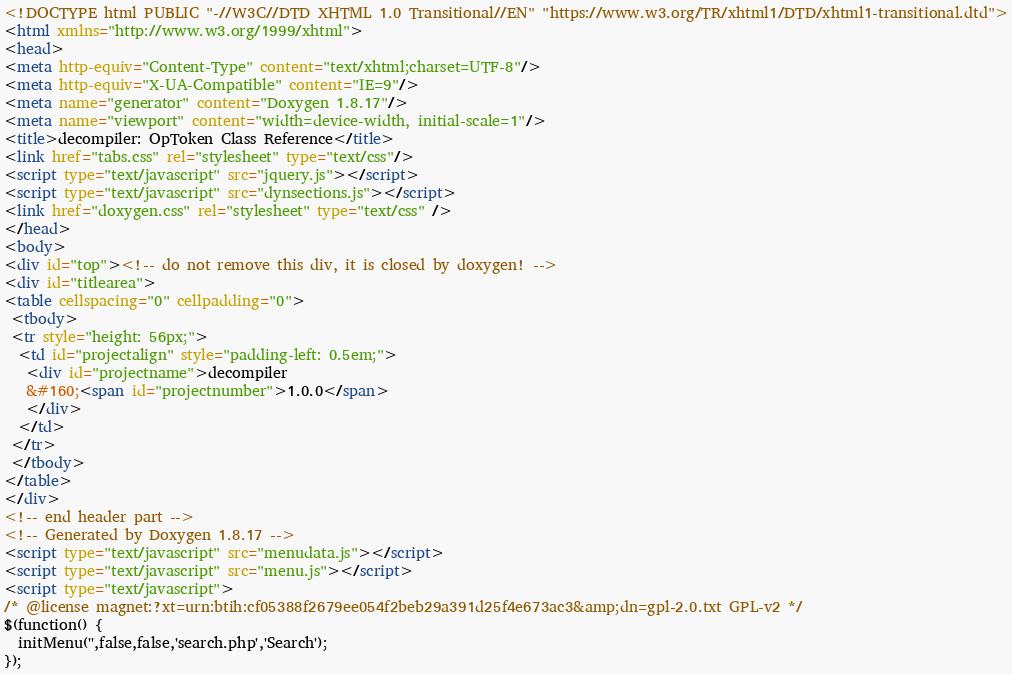Convert code to text. <code><loc_0><loc_0><loc_500><loc_500><_HTML_><!DOCTYPE html PUBLIC "-//W3C//DTD XHTML 1.0 Transitional//EN" "https://www.w3.org/TR/xhtml1/DTD/xhtml1-transitional.dtd">
<html xmlns="http://www.w3.org/1999/xhtml">
<head>
<meta http-equiv="Content-Type" content="text/xhtml;charset=UTF-8"/>
<meta http-equiv="X-UA-Compatible" content="IE=9"/>
<meta name="generator" content="Doxygen 1.8.17"/>
<meta name="viewport" content="width=device-width, initial-scale=1"/>
<title>decompiler: OpToken Class Reference</title>
<link href="tabs.css" rel="stylesheet" type="text/css"/>
<script type="text/javascript" src="jquery.js"></script>
<script type="text/javascript" src="dynsections.js"></script>
<link href="doxygen.css" rel="stylesheet" type="text/css" />
</head>
<body>
<div id="top"><!-- do not remove this div, it is closed by doxygen! -->
<div id="titlearea">
<table cellspacing="0" cellpadding="0">
 <tbody>
 <tr style="height: 56px;">
  <td id="projectalign" style="padding-left: 0.5em;">
   <div id="projectname">decompiler
   &#160;<span id="projectnumber">1.0.0</span>
   </div>
  </td>
 </tr>
 </tbody>
</table>
</div>
<!-- end header part -->
<!-- Generated by Doxygen 1.8.17 -->
<script type="text/javascript" src="menudata.js"></script>
<script type="text/javascript" src="menu.js"></script>
<script type="text/javascript">
/* @license magnet:?xt=urn:btih:cf05388f2679ee054f2beb29a391d25f4e673ac3&amp;dn=gpl-2.0.txt GPL-v2 */
$(function() {
  initMenu('',false,false,'search.php','Search');
});</code> 